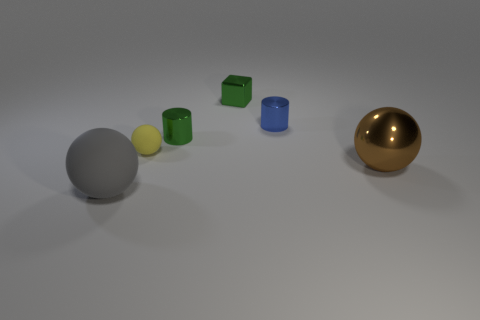There is a tiny thing that is the same shape as the big shiny thing; what is its material?
Offer a terse response. Rubber. There is a cylinder that is the same color as the metallic block; what size is it?
Offer a terse response. Small. Are there any balls left of the small block?
Provide a succinct answer. Yes. There is a green shiny object right of the green metallic cylinder; what number of tiny green cubes are right of it?
Make the answer very short. 0. There is a yellow ball; is its size the same as the blue cylinder that is right of the green block?
Your response must be concise. Yes. Are there any blocks that have the same color as the small ball?
Provide a short and direct response. No. There is a blue cylinder that is the same material as the tiny block; what size is it?
Your answer should be compact. Small. Does the small ball have the same material as the blue cylinder?
Offer a very short reply. No. What color is the small metal thing that is behind the metallic cylinder behind the green metal thing that is in front of the small blue object?
Give a very brief answer. Green. What shape is the large gray object?
Your answer should be very brief. Sphere. 